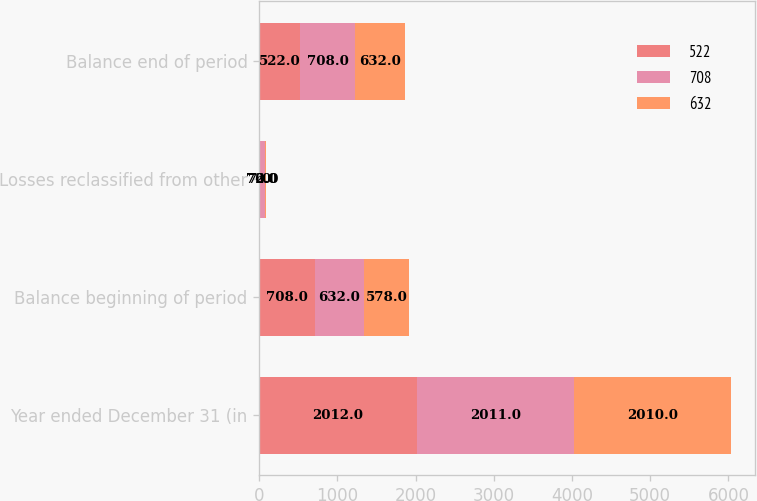Convert chart to OTSL. <chart><loc_0><loc_0><loc_500><loc_500><stacked_bar_chart><ecel><fcel>Year ended December 31 (in<fcel>Balance beginning of period<fcel>Losses reclassified from other<fcel>Balance end of period<nl><fcel>522<fcel>2012<fcel>708<fcel>7<fcel>522<nl><fcel>708<fcel>2011<fcel>632<fcel>72<fcel>708<nl><fcel>632<fcel>2010<fcel>578<fcel>6<fcel>632<nl></chart> 